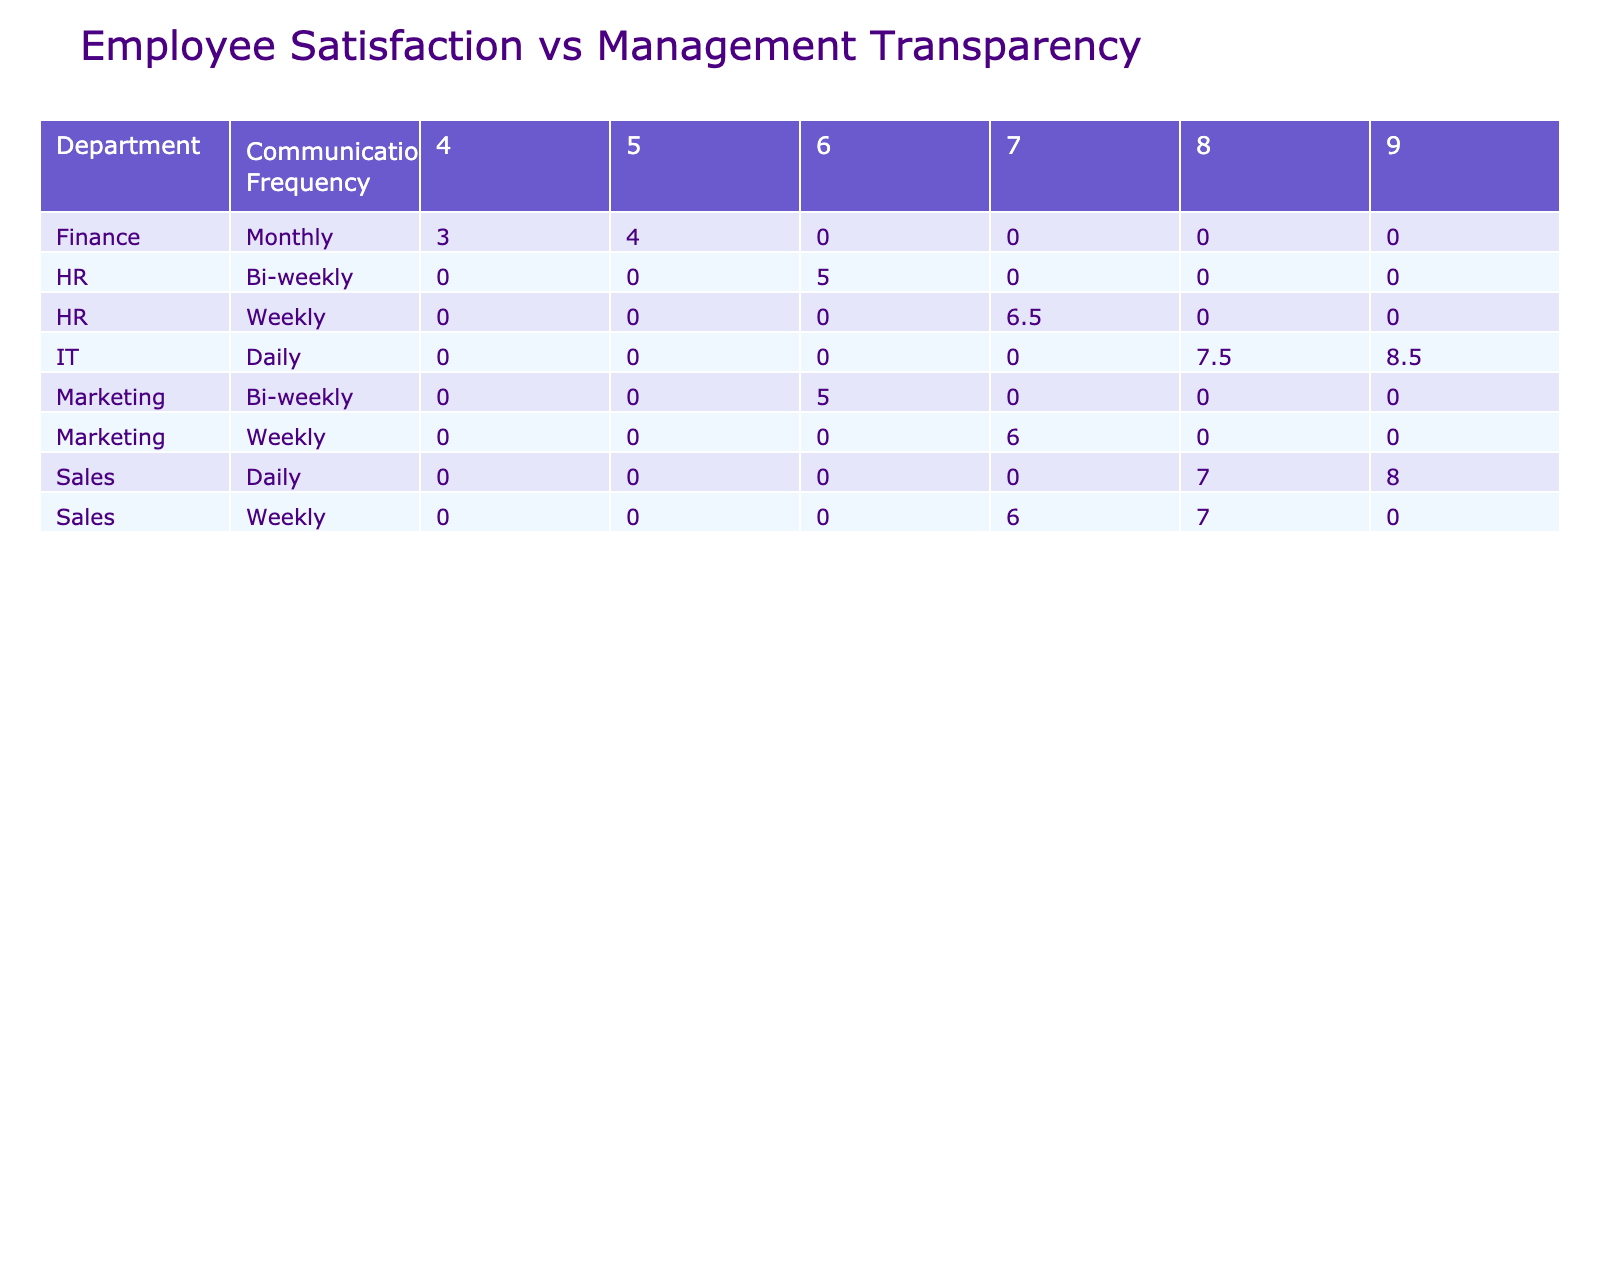What is the average Employee Satisfaction Score for the Sales department with a Management Transparency Score of 9? There are two entries in the Sales department with a Management Transparency Score of 9, which are E016 and the average Employee Satisfaction Score is (8 + 8) / 2 = 8
Answer: 8 What is the maximum Employee Satisfaction Score for the Finance department? The entries from the Finance department are: E005 (4), E010 (3), and E015 (4). The highest score among these is 4.
Answer: 4 Does the HR department have an Employee Satisfaction Score of 7 with a Management Transparency Score of 7? Yes, in the HR department, E014 has a Management Transparency Score of 7 and an Employee Satisfaction Score of 7.
Answer: Yes Which department has the lowest average satisfaction score for employees with a Management Transparency Score of 4? The Finance department has a Management Transparency Score of 4, with an Employee Satisfaction Score averaging at (3 + 4) / 2 = 3.5. This is the lowest among other departments with the same Management Transparency Score.
Answer: Finance What is the relationship between Communication Frequency and Employee Satisfaction Score for employees in the IT department? Analyzing the IT department: E003 has a Daily frequency with 8, E007 has Daily with 9, and E012 has Daily with 8. All scores are high (8 or 9) while for Bi-weekly, E017 has 7. Thus, IT shows better satisfaction with Daily communication.
Answer: Better with Daily communication What is the average Employee Satisfaction Score across all departments for employees with a Management Transparency Score of 8? The employees with a Management Transparency Score of 8 are: E003 (8), E006 (7), E012 (8), and E016 (8). Adding these scores gives 31, and dividing by 4 yields an average of 7.75.
Answer: 7.75 Are there any employees in the Marketing department who have a Communication Frequency of Monthly? No, all entries for the Marketing department have either Weekly or Bi-weekly communication frequencies; none are Monthly.
Answer: No Which department has the highest average Employee Satisfaction Score? The IT department has the highest Employee Satisfaction Scores recorded: averaged scores are 8.33 (from E003, E007, and E012).
Answer: IT 